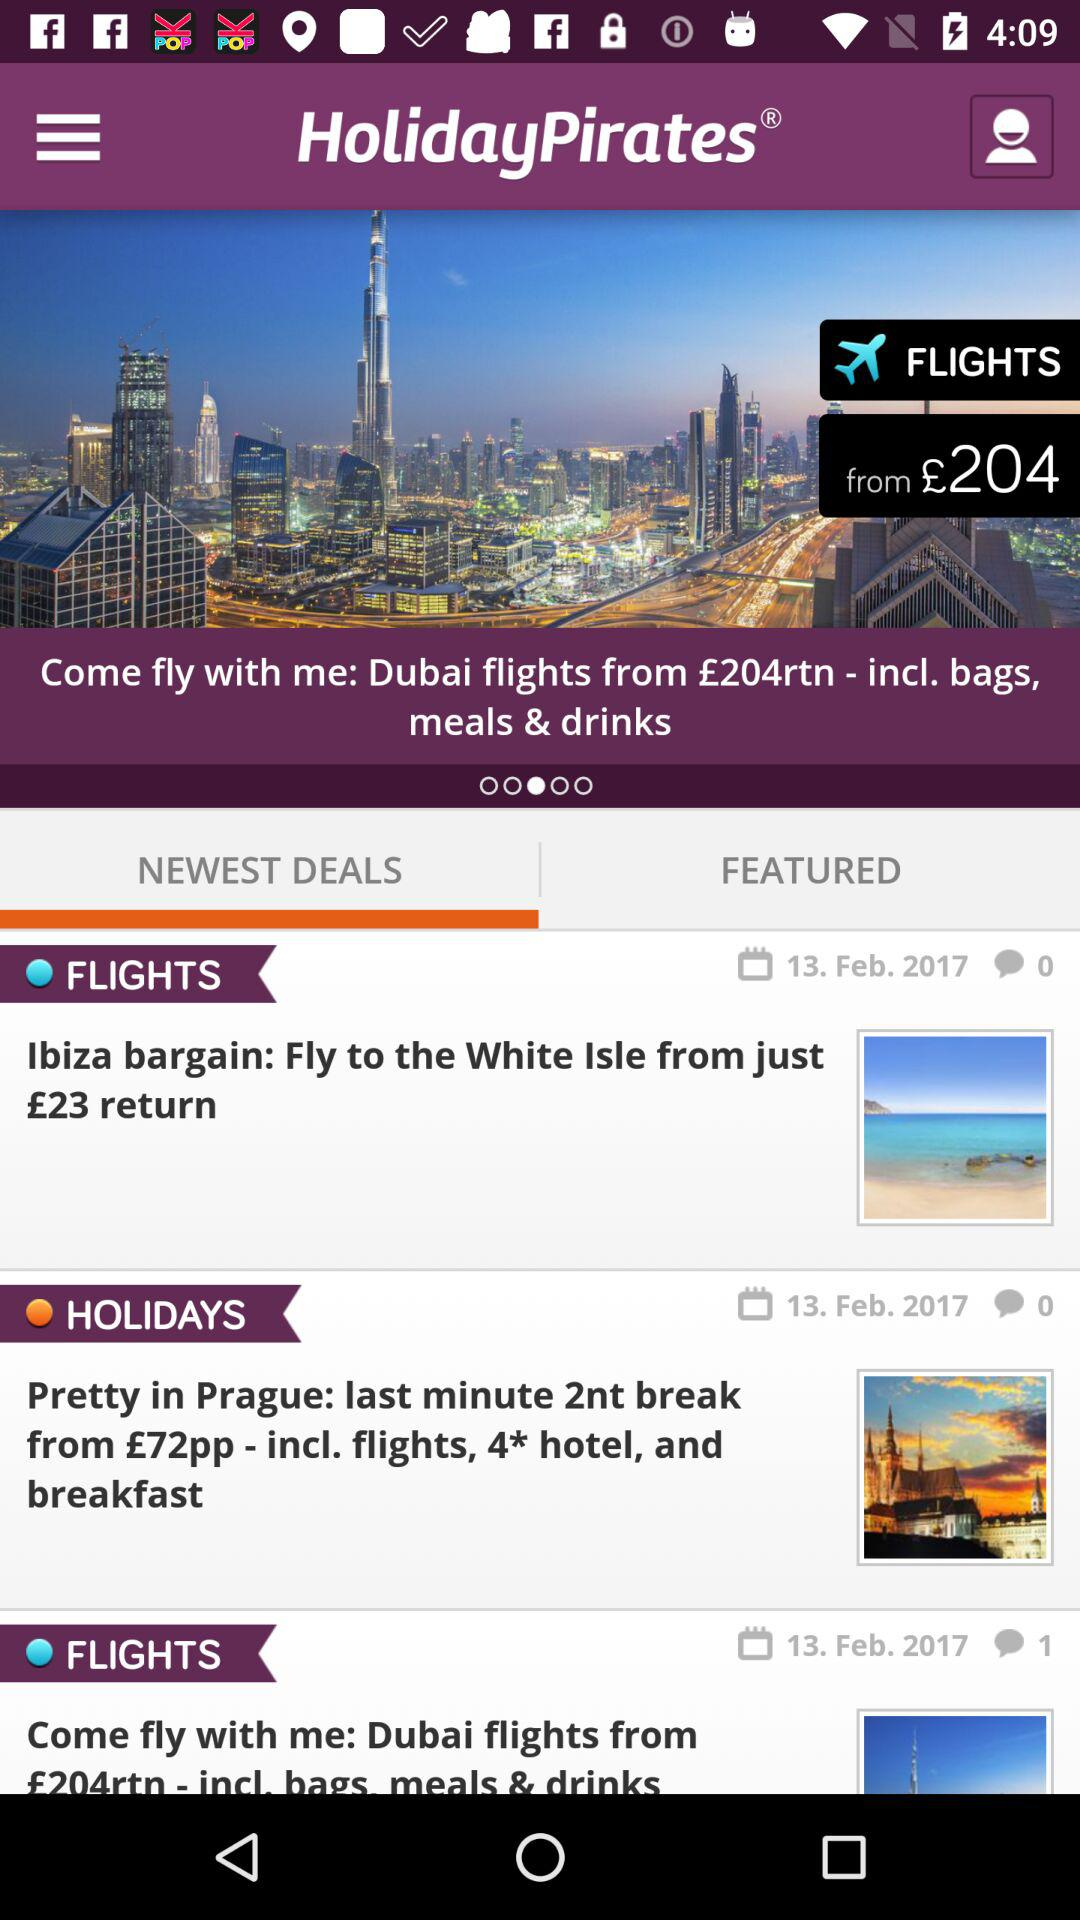Which tab is selected? The selected tab is "NEWEST DEALS". 